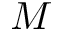Convert formula to latex. <formula><loc_0><loc_0><loc_500><loc_500>M</formula> 